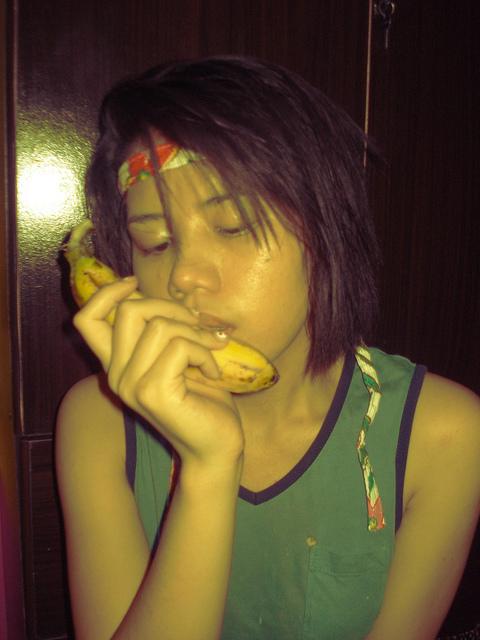Is she kissing the banana?
Give a very brief answer. No. Is this a telephone?
Be succinct. No. What is she holding?
Quick response, please. Banana. 